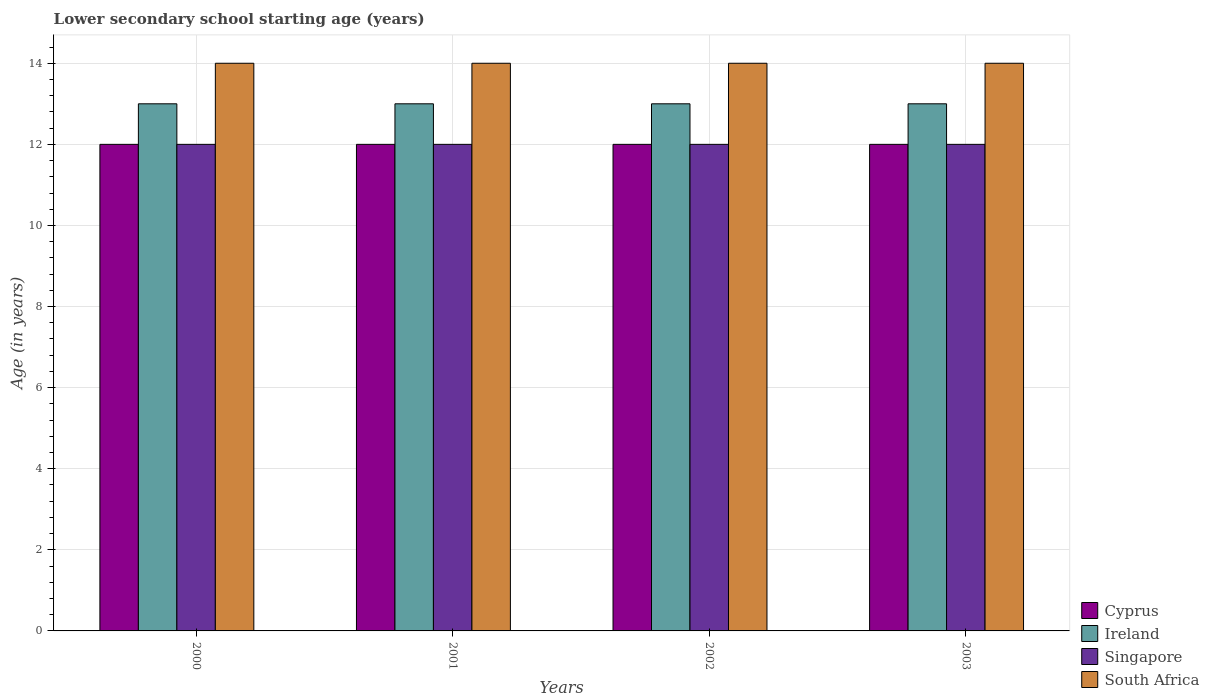How many groups of bars are there?
Your answer should be compact. 4. Are the number of bars per tick equal to the number of legend labels?
Your answer should be compact. Yes. In how many cases, is the number of bars for a given year not equal to the number of legend labels?
Your answer should be very brief. 0. What is the lower secondary school starting age of children in Singapore in 2001?
Keep it short and to the point. 12. Across all years, what is the maximum lower secondary school starting age of children in South Africa?
Offer a terse response. 14. Across all years, what is the minimum lower secondary school starting age of children in Singapore?
Provide a succinct answer. 12. In which year was the lower secondary school starting age of children in Ireland maximum?
Your answer should be very brief. 2000. What is the total lower secondary school starting age of children in Ireland in the graph?
Provide a succinct answer. 52. What is the difference between the lower secondary school starting age of children in Ireland in 2000 and the lower secondary school starting age of children in Singapore in 2003?
Give a very brief answer. 1. What is the average lower secondary school starting age of children in Cyprus per year?
Offer a very short reply. 12. In the year 2002, what is the difference between the lower secondary school starting age of children in Singapore and lower secondary school starting age of children in South Africa?
Provide a short and direct response. -2. In how many years, is the lower secondary school starting age of children in South Africa greater than 11.2 years?
Your response must be concise. 4. What is the ratio of the lower secondary school starting age of children in South Africa in 2001 to that in 2002?
Provide a succinct answer. 1. Is the lower secondary school starting age of children in Cyprus in 2000 less than that in 2002?
Make the answer very short. No. Is the difference between the lower secondary school starting age of children in Singapore in 2000 and 2003 greater than the difference between the lower secondary school starting age of children in South Africa in 2000 and 2003?
Give a very brief answer. No. What is the difference between the highest and the second highest lower secondary school starting age of children in South Africa?
Offer a terse response. 0. What is the difference between the highest and the lowest lower secondary school starting age of children in South Africa?
Your answer should be compact. 0. In how many years, is the lower secondary school starting age of children in Singapore greater than the average lower secondary school starting age of children in Singapore taken over all years?
Your answer should be compact. 0. Is the sum of the lower secondary school starting age of children in Cyprus in 2002 and 2003 greater than the maximum lower secondary school starting age of children in South Africa across all years?
Your answer should be compact. Yes. What does the 1st bar from the left in 2000 represents?
Give a very brief answer. Cyprus. What does the 3rd bar from the right in 2000 represents?
Keep it short and to the point. Ireland. Is it the case that in every year, the sum of the lower secondary school starting age of children in Ireland and lower secondary school starting age of children in Singapore is greater than the lower secondary school starting age of children in South Africa?
Your answer should be compact. Yes. Are the values on the major ticks of Y-axis written in scientific E-notation?
Your answer should be compact. No. Does the graph contain any zero values?
Offer a terse response. No. Does the graph contain grids?
Offer a terse response. Yes. Where does the legend appear in the graph?
Ensure brevity in your answer.  Bottom right. How many legend labels are there?
Ensure brevity in your answer.  4. How are the legend labels stacked?
Offer a terse response. Vertical. What is the title of the graph?
Provide a succinct answer. Lower secondary school starting age (years). What is the label or title of the Y-axis?
Keep it short and to the point. Age (in years). What is the Age (in years) of Cyprus in 2000?
Offer a terse response. 12. What is the Age (in years) in South Africa in 2000?
Provide a succinct answer. 14. What is the Age (in years) of Cyprus in 2001?
Give a very brief answer. 12. What is the Age (in years) in Singapore in 2001?
Provide a short and direct response. 12. What is the Age (in years) in South Africa in 2001?
Make the answer very short. 14. What is the Age (in years) of Ireland in 2002?
Your answer should be very brief. 13. What is the Age (in years) of Singapore in 2002?
Your response must be concise. 12. What is the Age (in years) of South Africa in 2002?
Your answer should be compact. 14. What is the Age (in years) of Cyprus in 2003?
Ensure brevity in your answer.  12. What is the Age (in years) of Singapore in 2003?
Offer a very short reply. 12. What is the Age (in years) of South Africa in 2003?
Make the answer very short. 14. Across all years, what is the maximum Age (in years) of Cyprus?
Keep it short and to the point. 12. Across all years, what is the maximum Age (in years) of Ireland?
Offer a very short reply. 13. Across all years, what is the maximum Age (in years) in Singapore?
Your answer should be compact. 12. Across all years, what is the maximum Age (in years) of South Africa?
Offer a very short reply. 14. Across all years, what is the minimum Age (in years) in Cyprus?
Provide a short and direct response. 12. Across all years, what is the minimum Age (in years) of Singapore?
Your answer should be compact. 12. What is the total Age (in years) of Singapore in the graph?
Your answer should be compact. 48. What is the difference between the Age (in years) in Cyprus in 2000 and that in 2001?
Ensure brevity in your answer.  0. What is the difference between the Age (in years) in Ireland in 2000 and that in 2001?
Offer a terse response. 0. What is the difference between the Age (in years) of Singapore in 2000 and that in 2001?
Keep it short and to the point. 0. What is the difference between the Age (in years) in South Africa in 2000 and that in 2001?
Ensure brevity in your answer.  0. What is the difference between the Age (in years) in Cyprus in 2000 and that in 2002?
Make the answer very short. 0. What is the difference between the Age (in years) of South Africa in 2000 and that in 2002?
Provide a succinct answer. 0. What is the difference between the Age (in years) in Cyprus in 2000 and that in 2003?
Your answer should be very brief. 0. What is the difference between the Age (in years) of Cyprus in 2001 and that in 2002?
Keep it short and to the point. 0. What is the difference between the Age (in years) in Ireland in 2001 and that in 2002?
Keep it short and to the point. 0. What is the difference between the Age (in years) of Singapore in 2001 and that in 2002?
Your answer should be very brief. 0. What is the difference between the Age (in years) of Cyprus in 2001 and that in 2003?
Your answer should be very brief. 0. What is the difference between the Age (in years) of Cyprus in 2002 and that in 2003?
Your answer should be very brief. 0. What is the difference between the Age (in years) in South Africa in 2002 and that in 2003?
Provide a short and direct response. 0. What is the difference between the Age (in years) of Ireland in 2000 and the Age (in years) of Singapore in 2001?
Give a very brief answer. 1. What is the difference between the Age (in years) in Ireland in 2000 and the Age (in years) in South Africa in 2001?
Keep it short and to the point. -1. What is the difference between the Age (in years) in Singapore in 2000 and the Age (in years) in South Africa in 2001?
Make the answer very short. -2. What is the difference between the Age (in years) in Cyprus in 2000 and the Age (in years) in Ireland in 2002?
Give a very brief answer. -1. What is the difference between the Age (in years) in Cyprus in 2000 and the Age (in years) in Singapore in 2002?
Keep it short and to the point. 0. What is the difference between the Age (in years) of Cyprus in 2000 and the Age (in years) of South Africa in 2002?
Provide a short and direct response. -2. What is the difference between the Age (in years) in Ireland in 2000 and the Age (in years) in South Africa in 2002?
Ensure brevity in your answer.  -1. What is the difference between the Age (in years) of Singapore in 2000 and the Age (in years) of South Africa in 2002?
Offer a very short reply. -2. What is the difference between the Age (in years) of Cyprus in 2000 and the Age (in years) of Singapore in 2003?
Your answer should be compact. 0. What is the difference between the Age (in years) of Cyprus in 2000 and the Age (in years) of South Africa in 2003?
Your answer should be very brief. -2. What is the difference between the Age (in years) in Ireland in 2000 and the Age (in years) in South Africa in 2003?
Make the answer very short. -1. What is the difference between the Age (in years) of Singapore in 2000 and the Age (in years) of South Africa in 2003?
Offer a very short reply. -2. What is the difference between the Age (in years) of Cyprus in 2001 and the Age (in years) of Ireland in 2002?
Your answer should be compact. -1. What is the difference between the Age (in years) of Cyprus in 2001 and the Age (in years) of South Africa in 2002?
Your answer should be very brief. -2. What is the difference between the Age (in years) of Ireland in 2001 and the Age (in years) of Singapore in 2002?
Your response must be concise. 1. What is the difference between the Age (in years) in Ireland in 2001 and the Age (in years) in South Africa in 2002?
Ensure brevity in your answer.  -1. What is the difference between the Age (in years) of Singapore in 2001 and the Age (in years) of South Africa in 2002?
Offer a very short reply. -2. What is the difference between the Age (in years) in Cyprus in 2001 and the Age (in years) in Singapore in 2003?
Offer a very short reply. 0. What is the difference between the Age (in years) in Singapore in 2001 and the Age (in years) in South Africa in 2003?
Provide a short and direct response. -2. What is the difference between the Age (in years) of Ireland in 2002 and the Age (in years) of Singapore in 2003?
Provide a succinct answer. 1. What is the difference between the Age (in years) of Ireland in 2002 and the Age (in years) of South Africa in 2003?
Provide a succinct answer. -1. What is the difference between the Age (in years) of Singapore in 2002 and the Age (in years) of South Africa in 2003?
Your answer should be very brief. -2. What is the average Age (in years) in Cyprus per year?
Provide a short and direct response. 12. What is the average Age (in years) in Ireland per year?
Provide a succinct answer. 13. What is the average Age (in years) of South Africa per year?
Offer a terse response. 14. In the year 2000, what is the difference between the Age (in years) of Cyprus and Age (in years) of South Africa?
Offer a very short reply. -2. In the year 2000, what is the difference between the Age (in years) in Singapore and Age (in years) in South Africa?
Make the answer very short. -2. In the year 2001, what is the difference between the Age (in years) of Cyprus and Age (in years) of Ireland?
Offer a very short reply. -1. In the year 2001, what is the difference between the Age (in years) in Cyprus and Age (in years) in Singapore?
Provide a short and direct response. 0. In the year 2001, what is the difference between the Age (in years) of Cyprus and Age (in years) of South Africa?
Offer a terse response. -2. In the year 2001, what is the difference between the Age (in years) of Ireland and Age (in years) of Singapore?
Provide a succinct answer. 1. In the year 2002, what is the difference between the Age (in years) in Cyprus and Age (in years) in Singapore?
Your answer should be very brief. 0. In the year 2002, what is the difference between the Age (in years) of Ireland and Age (in years) of Singapore?
Keep it short and to the point. 1. In the year 2002, what is the difference between the Age (in years) in Ireland and Age (in years) in South Africa?
Provide a succinct answer. -1. In the year 2002, what is the difference between the Age (in years) in Singapore and Age (in years) in South Africa?
Your response must be concise. -2. In the year 2003, what is the difference between the Age (in years) of Cyprus and Age (in years) of Singapore?
Offer a terse response. 0. In the year 2003, what is the difference between the Age (in years) of Cyprus and Age (in years) of South Africa?
Provide a short and direct response. -2. In the year 2003, what is the difference between the Age (in years) of Ireland and Age (in years) of South Africa?
Provide a succinct answer. -1. In the year 2003, what is the difference between the Age (in years) in Singapore and Age (in years) in South Africa?
Provide a succinct answer. -2. What is the ratio of the Age (in years) of Ireland in 2000 to that in 2001?
Your response must be concise. 1. What is the ratio of the Age (in years) in Singapore in 2000 to that in 2001?
Keep it short and to the point. 1. What is the ratio of the Age (in years) in South Africa in 2000 to that in 2001?
Your answer should be very brief. 1. What is the ratio of the Age (in years) in Cyprus in 2000 to that in 2002?
Provide a short and direct response. 1. What is the ratio of the Age (in years) in Ireland in 2000 to that in 2002?
Your response must be concise. 1. What is the ratio of the Age (in years) of South Africa in 2000 to that in 2002?
Your answer should be compact. 1. What is the ratio of the Age (in years) of Ireland in 2000 to that in 2003?
Offer a terse response. 1. What is the ratio of the Age (in years) of Singapore in 2000 to that in 2003?
Your answer should be very brief. 1. What is the ratio of the Age (in years) of Cyprus in 2001 to that in 2002?
Offer a very short reply. 1. What is the ratio of the Age (in years) of Singapore in 2001 to that in 2002?
Ensure brevity in your answer.  1. What is the ratio of the Age (in years) of Cyprus in 2001 to that in 2003?
Offer a terse response. 1. What is the ratio of the Age (in years) in Ireland in 2001 to that in 2003?
Offer a terse response. 1. What is the ratio of the Age (in years) in Singapore in 2001 to that in 2003?
Provide a succinct answer. 1. What is the ratio of the Age (in years) of South Africa in 2001 to that in 2003?
Make the answer very short. 1. What is the ratio of the Age (in years) in Ireland in 2002 to that in 2003?
Provide a succinct answer. 1. What is the ratio of the Age (in years) of Singapore in 2002 to that in 2003?
Your answer should be very brief. 1. What is the ratio of the Age (in years) of South Africa in 2002 to that in 2003?
Offer a very short reply. 1. What is the difference between the highest and the lowest Age (in years) of Cyprus?
Make the answer very short. 0. What is the difference between the highest and the lowest Age (in years) in Ireland?
Provide a short and direct response. 0. What is the difference between the highest and the lowest Age (in years) in South Africa?
Your answer should be compact. 0. 